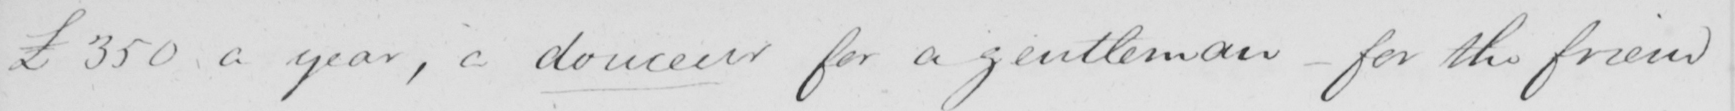Can you read and transcribe this handwriting? £350 a year , a douceur for a gentleman  _  for the friend 